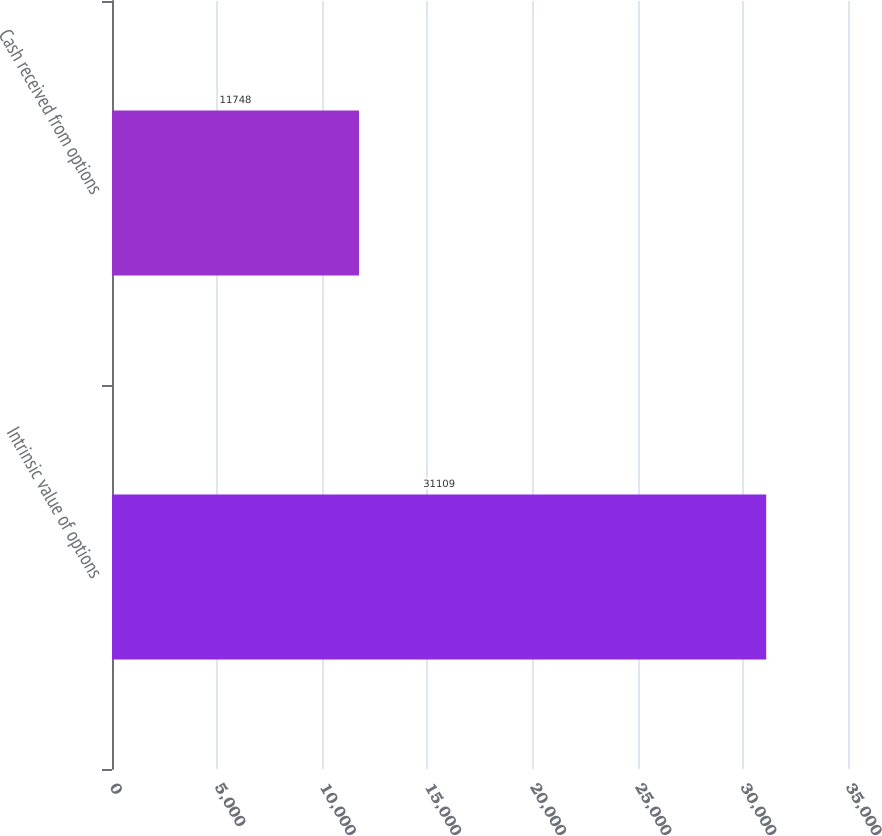Convert chart to OTSL. <chart><loc_0><loc_0><loc_500><loc_500><bar_chart><fcel>Intrinsic value of options<fcel>Cash received from options<nl><fcel>31109<fcel>11748<nl></chart> 